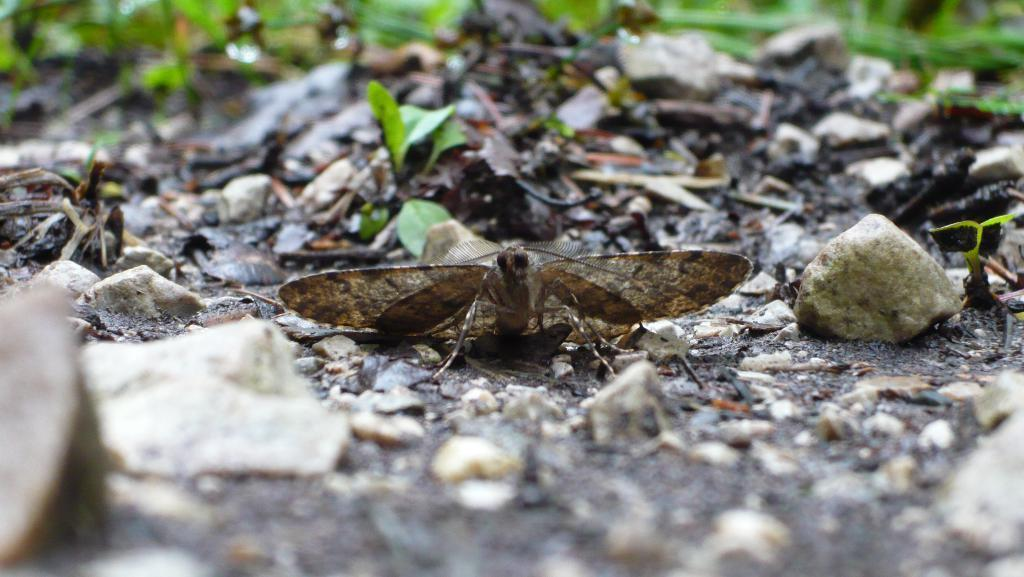What type of insect is present in the image? There is a brown color butterfly in the image. Where is the butterfly located in the image? The butterfly is sitting on the ground. What can be seen on the ground in the image? Dry leaves are visible in the image. How would you describe the background of the image? The background of the image is blurred. What type of notebook is the butterfly using to write in the image? There is no notebook present in the image, and butterflies do not have the ability to write. 